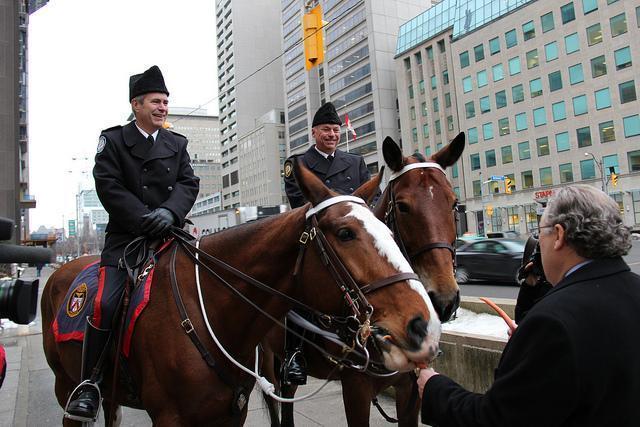How many horses?
Give a very brief answer. 2. How many pairs of glasses?
Give a very brief answer. 1. How many horses can you see?
Give a very brief answer. 2. How many people are in the picture?
Give a very brief answer. 3. 